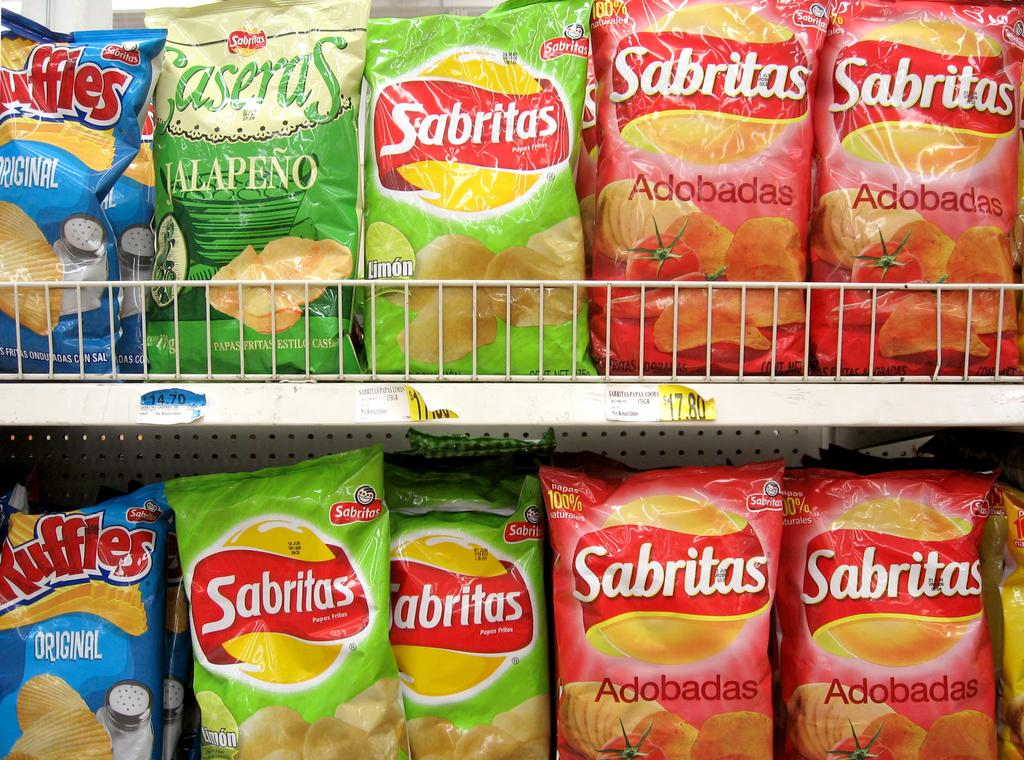What can be seen on the shelves in the image? There are chips packets on the shelves. What is located in the center of the image? There are papers in the center of the image. What can be observed about the papers? Something is written on the papers. How many houses can be seen in the image? There are no houses present in the image. What type of bubble is visible in the image? There is no bubble present in the image. 